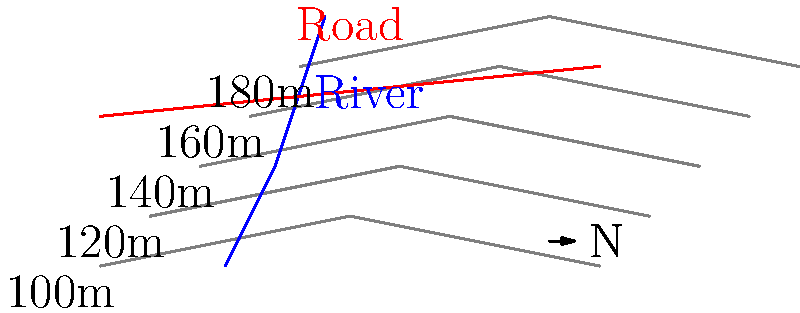Based on the topographical map provided, which area would be most suitable for constructing guest accommodations on your property adjacent to the national park? Consider factors such as accessibility, scenic views, and minimal environmental impact. To determine the most suitable location for guest accommodations, we need to analyze the topographical map considering several factors:

1. Elevation: The map shows contour lines representing elevation changes. Each line represents a 20m increase in elevation from the previous line.

2. Accessibility: The red line represents a road, which is crucial for easy access to the accommodations.

3. Water features: The blue line represents a river, which can provide scenic views but may also pose flooding risks.

4. Slope: Areas with widely spaced contour lines indicate gentler slopes, which are more suitable for construction.

5. Environmental impact: We should avoid areas close to the river to minimize environmental impact.

Analyzing the map:

1. The area between the 120m and 140m contour lines, near the road (top right quadrant), offers a good balance of factors:
   - It's easily accessible due to proximity to the road.
   - It's on a relatively gentle slope (contour lines are not too close together).
   - It's far enough from the river to avoid flooding risks and minimize environmental impact.
   - It's at a higher elevation, potentially offering good views of the surrounding area.

2. The area below the 120m contour line is too close to the river and may be prone to flooding.

3. Areas above the 140m contour line have steeper slopes, making construction more challenging and potentially more disruptive to the environment.

Therefore, the most suitable location for guest accommodations would be in the area between the 120m and 140m contour lines, close to where the road intersects these contours.
Answer: Between 120m and 140m contour lines, near the road intersection 